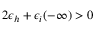Convert formula to latex. <formula><loc_0><loc_0><loc_500><loc_500>2 \epsilon _ { h } + \epsilon _ { i } ( - \infty ) > 0</formula> 